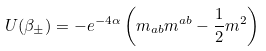<formula> <loc_0><loc_0><loc_500><loc_500>U ( \beta _ { \pm } ) = - e ^ { - 4 \alpha } \left ( m _ { a b } m ^ { a b } - \frac { 1 } { 2 } m ^ { 2 } \right )</formula> 